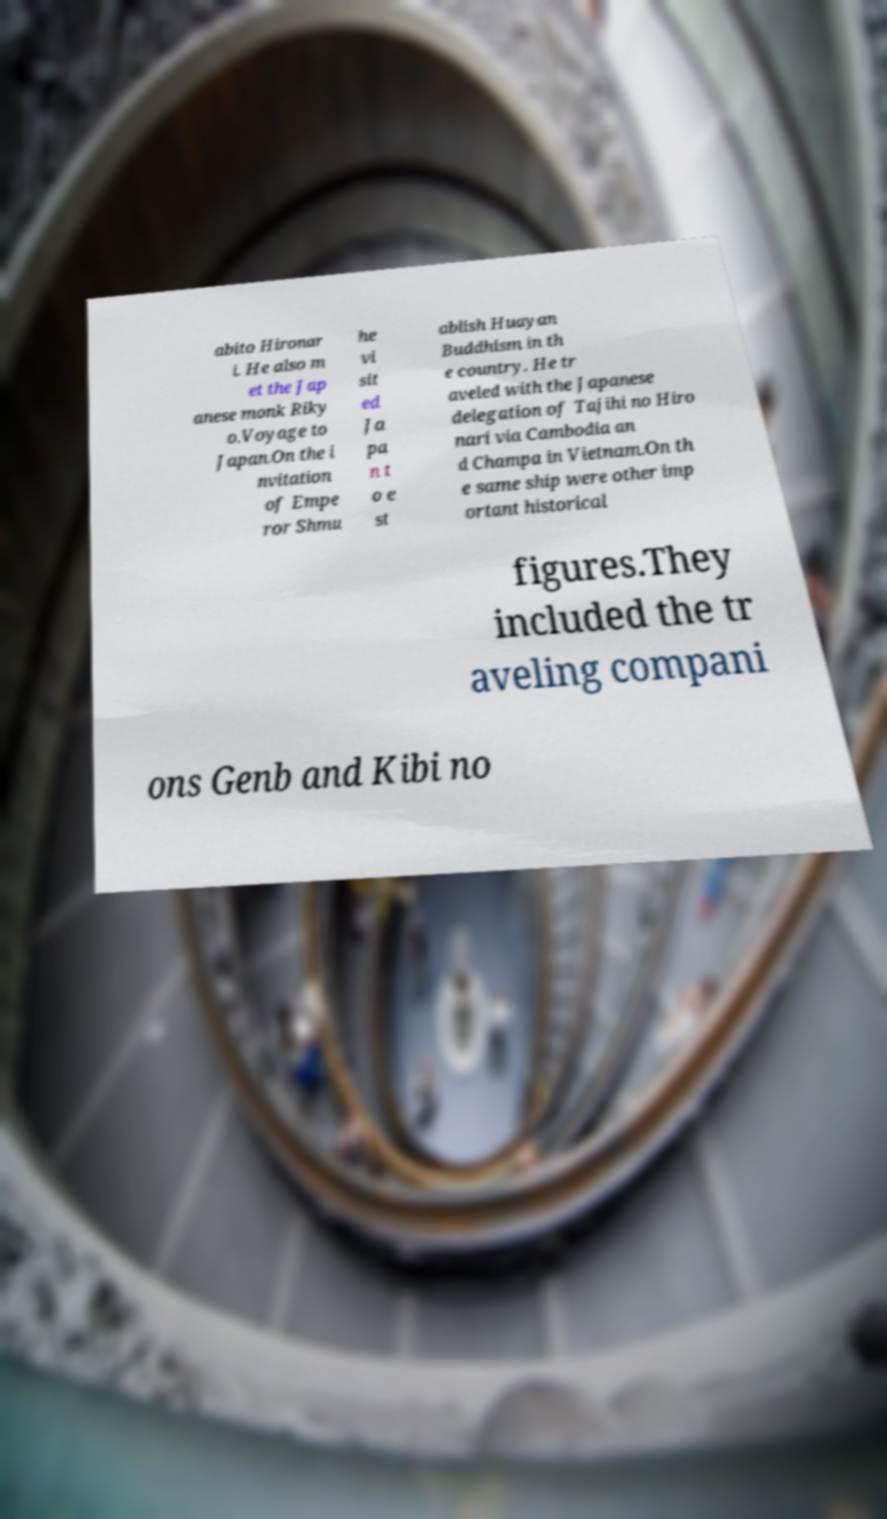Please read and relay the text visible in this image. What does it say? abito Hironar i. He also m et the Jap anese monk Riky o.Voyage to Japan.On the i nvitation of Empe ror Shmu he vi sit ed Ja pa n t o e st ablish Huayan Buddhism in th e country. He tr aveled with the Japanese delegation of Tajihi no Hiro nari via Cambodia an d Champa in Vietnam.On th e same ship were other imp ortant historical figures.They included the tr aveling compani ons Genb and Kibi no 